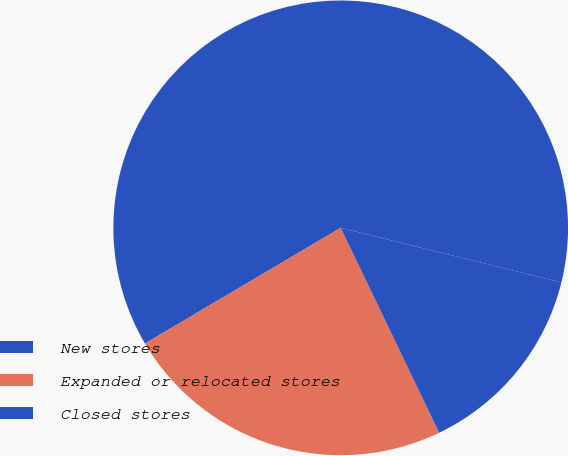Convert chart to OTSL. <chart><loc_0><loc_0><loc_500><loc_500><pie_chart><fcel>New stores<fcel>Expanded or relocated stores<fcel>Closed stores<nl><fcel>62.36%<fcel>23.63%<fcel>14.01%<nl></chart> 